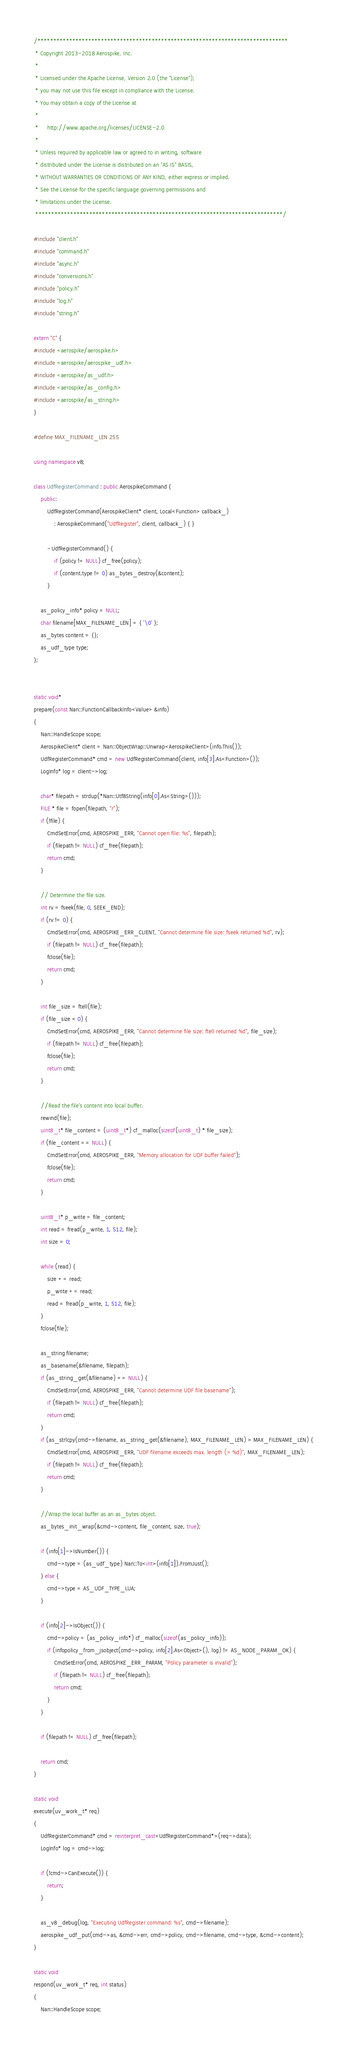<code> <loc_0><loc_0><loc_500><loc_500><_C++_>/*******************************************************************************
 * Copyright 2013-2018 Aerospike, Inc.
 *
 * Licensed under the Apache License, Version 2.0 (the "License");
 * you may not use this file except in compliance with the License.
 * You may obtain a copy of the License at
 *
 *     http://www.apache.org/licenses/LICENSE-2.0
 *
 * Unless required by applicable law or agreed to in writing, software
 * distributed under the License is distributed on an "AS IS" BASIS,
 * WITHOUT WARRANTIES OR CONDITIONS OF ANY KIND, either express or implied.
 * See the License for the specific language governing permissions and
 * limitations under the License.
 ******************************************************************************/

#include "client.h"
#include "command.h"
#include "async.h"
#include "conversions.h"
#include "policy.h"
#include "log.h"
#include "string.h"

extern "C" {
#include <aerospike/aerospike.h>
#include <aerospike/aerospike_udf.h>
#include <aerospike/as_udf.h>
#include <aerospike/as_config.h>
#include <aerospike/as_string.h>
}

#define MAX_FILENAME_LEN 255

using namespace v8;

class UdfRegisterCommand : public AerospikeCommand {
	public:
		UdfRegisterCommand(AerospikeClient* client, Local<Function> callback_)
			: AerospikeCommand("UdfRegister", client, callback_) { }

		~UdfRegisterCommand() {
			if (policy != NULL) cf_free(policy);
			if (content.type != 0) as_bytes_destroy(&content);
		}

	as_policy_info* policy = NULL;
	char filename[MAX_FILENAME_LEN] = { '\0' };
	as_bytes content = {};
	as_udf_type type;
};


static void*
prepare(const Nan::FunctionCallbackInfo<Value> &info)
{
	Nan::HandleScope scope;
	AerospikeClient* client = Nan::ObjectWrap::Unwrap<AerospikeClient>(info.This());
	UdfRegisterCommand* cmd = new UdfRegisterCommand(client, info[3].As<Function>());
	LogInfo* log = client->log;

	char* filepath = strdup(*Nan::Utf8String(info[0].As<String>()));
	FILE * file = fopen(filepath, "r");
	if (!file) {
		CmdSetError(cmd, AEROSPIKE_ERR, "Cannot open file: %s", filepath);
		if (filepath != NULL) cf_free(filepath);
		return cmd;
	}

	// Determine the file size.
	int rv = fseek(file, 0, SEEK_END);
	if (rv != 0) {
		CmdSetError(cmd, AEROSPIKE_ERR_CLIENT, "Cannot determine file size: fseek returned %d", rv);
		if (filepath != NULL) cf_free(filepath);
		fclose(file);
		return cmd;
	}

	int file_size = ftell(file);
	if (file_size < 0) {
		CmdSetError(cmd, AEROSPIKE_ERR, "Cannot determine file size: ftell returned %d", file_size);
		if (filepath != NULL) cf_free(filepath);
		fclose(file);
		return cmd;
	}

	//Read the file's content into local buffer.
	rewind(file);
	uint8_t* file_content = (uint8_t*) cf_malloc(sizeof(uint8_t) * file_size);
	if (file_content == NULL) {
		CmdSetError(cmd, AEROSPIKE_ERR, "Memory allocation for UDF buffer failed");
		fclose(file);
		return cmd;
	}

	uint8_t* p_write = file_content;
	int read = fread(p_write, 1, 512, file);
	int size = 0;

	while (read) {
		size += read;
		p_write += read;
		read = fread(p_write, 1, 512, file);
	}
	fclose(file);

	as_string filename;
	as_basename(&filename, filepath);
	if (as_string_get(&filename) == NULL) {
		CmdSetError(cmd, AEROSPIKE_ERR, "Cannot determine UDF file basename");
		if (filepath != NULL) cf_free(filepath);
		return cmd;
	}
	if (as_strlcpy(cmd->filename, as_string_get(&filename), MAX_FILENAME_LEN) > MAX_FILENAME_LEN) {
		CmdSetError(cmd, AEROSPIKE_ERR, "UDF filename exceeds max. length (> %d)", MAX_FILENAME_LEN);
		if (filepath != NULL) cf_free(filepath);
		return cmd;
	}

	//Wrap the local buffer as an as_bytes object.
	as_bytes_init_wrap(&cmd->content, file_content, size, true);

	if (info[1]->IsNumber()) {
		cmd->type = (as_udf_type) Nan::To<int>(info[1]).FromJust();
	} else {
		cmd->type = AS_UDF_TYPE_LUA;
	}

	if (info[2]->IsObject()) {
		cmd->policy = (as_policy_info*) cf_malloc(sizeof(as_policy_info));
		if (infopolicy_from_jsobject(cmd->policy, info[2].As<Object>(), log) != AS_NODE_PARAM_OK) {
			CmdSetError(cmd, AEROSPIKE_ERR_PARAM, "Policy parameter is invalid");
			if (filepath != NULL) cf_free(filepath);
			return cmd;
		}
	}

	if (filepath != NULL) cf_free(filepath);

	return cmd;
}

static void
execute(uv_work_t* req)
{
	UdfRegisterCommand* cmd = reinterpret_cast<UdfRegisterCommand*>(req->data);
	LogInfo* log = cmd->log;

	if (!cmd->CanExecute()) {
		return;
	}

	as_v8_debug(log, "Executing UdfRegister command: %s", cmd->filename);
	aerospike_udf_put(cmd->as, &cmd->err, cmd->policy, cmd->filename, cmd->type, &cmd->content);
}

static void
respond(uv_work_t* req, int status)
{
	Nan::HandleScope scope;</code> 